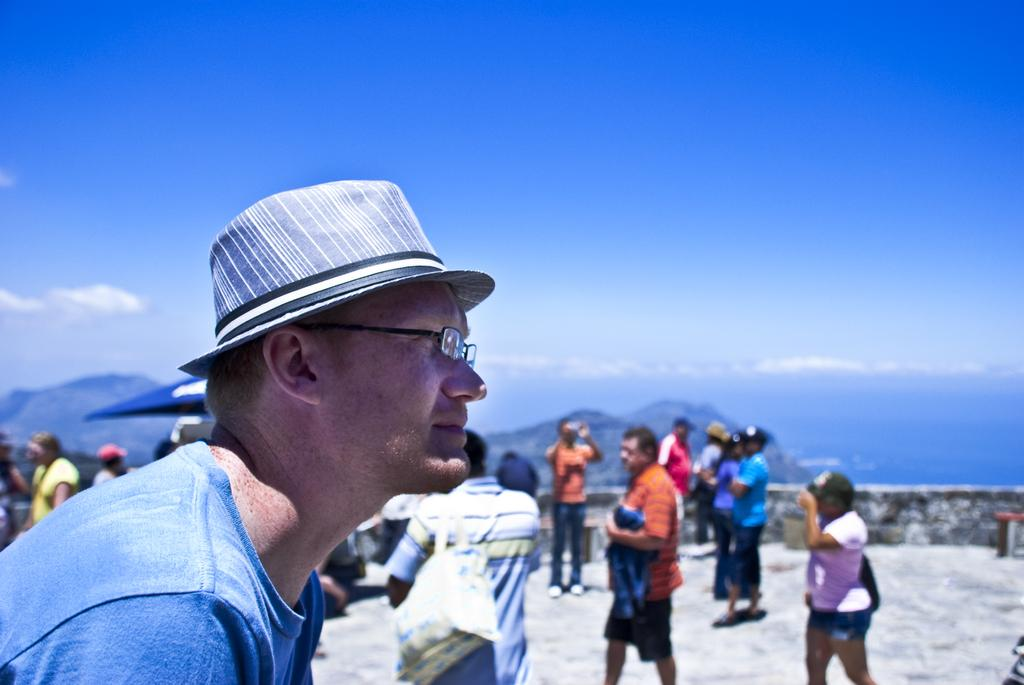What is located on the left side of the image? There is a person on the left side of the image. What accessories is the person wearing? The person is wearing a hat and glasses. How would you describe the background of the image? The background has a blurred view. Can you identify any other people in the image? Yes, there are people visible in the image. What kind of path can be seen in the image? There is a path in the image. What type of structure is present in the image? There is a wall in the image. What type of natural landscape is visible in the image? There are hills in the image. How many objects are present in the image? There are few objects in the image. What part of the environment is visible in the image? There is a sky visible in the image. How much salt is visible on the person's sneeze in the image? There is no salt or sneeze present in the image. What type of dirt can be seen on the person's shoes in the image? There is no dirt or shoes visible in the image. 